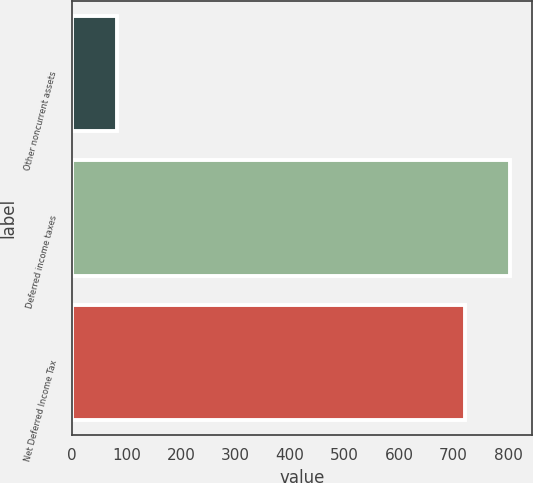Convert chart. <chart><loc_0><loc_0><loc_500><loc_500><bar_chart><fcel>Other noncurrent assets<fcel>Deferred income taxes<fcel>Net Deferred Income Tax<nl><fcel>82.7<fcel>803.4<fcel>720.7<nl></chart> 